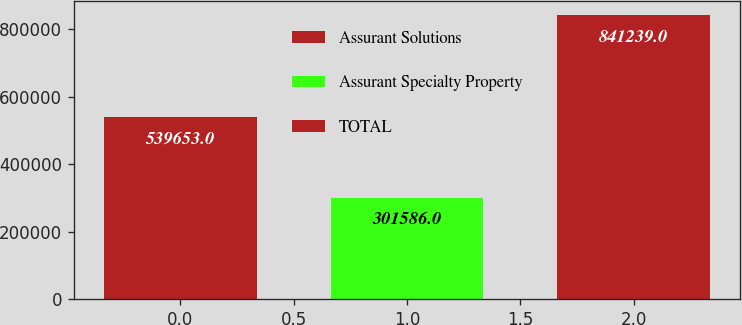Convert chart to OTSL. <chart><loc_0><loc_0><loc_500><loc_500><bar_chart><fcel>Assurant Solutions<fcel>Assurant Specialty Property<fcel>TOTAL<nl><fcel>539653<fcel>301586<fcel>841239<nl></chart> 